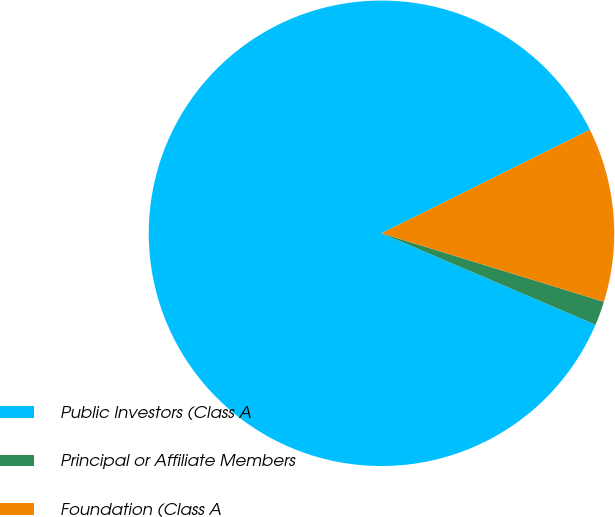<chart> <loc_0><loc_0><loc_500><loc_500><pie_chart><fcel>Public Investors (Class A<fcel>Principal or Affiliate Members<fcel>Foundation (Class A<nl><fcel>86.23%<fcel>1.67%<fcel>12.09%<nl></chart> 